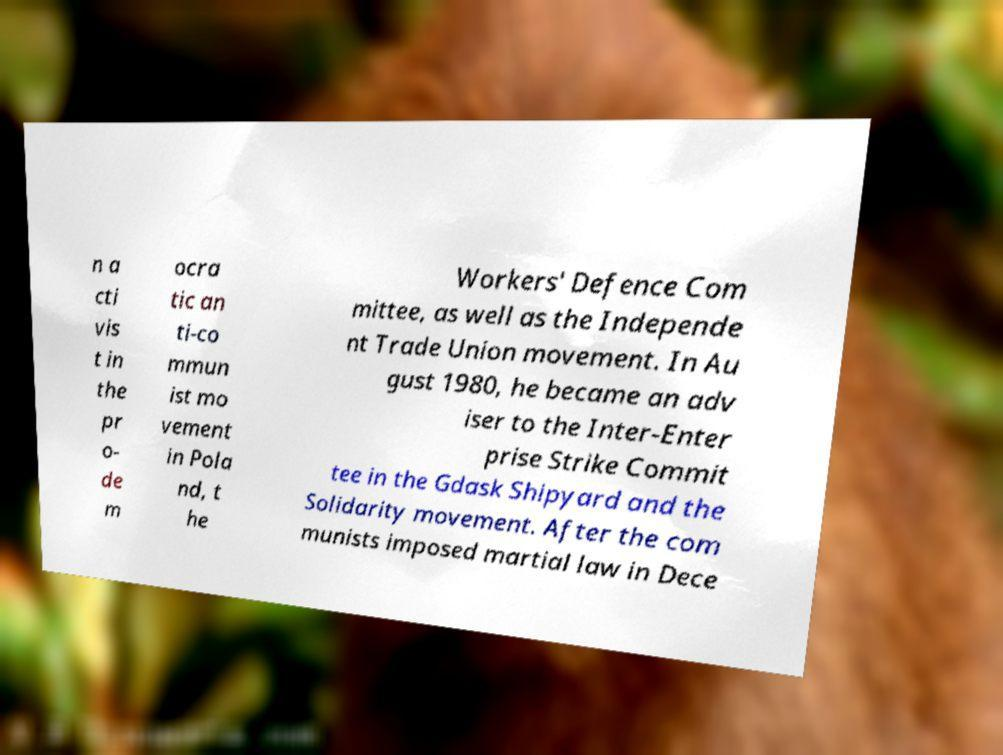What messages or text are displayed in this image? I need them in a readable, typed format. n a cti vis t in the pr o- de m ocra tic an ti-co mmun ist mo vement in Pola nd, t he Workers' Defence Com mittee, as well as the Independe nt Trade Union movement. In Au gust 1980, he became an adv iser to the Inter-Enter prise Strike Commit tee in the Gdask Shipyard and the Solidarity movement. After the com munists imposed martial law in Dece 